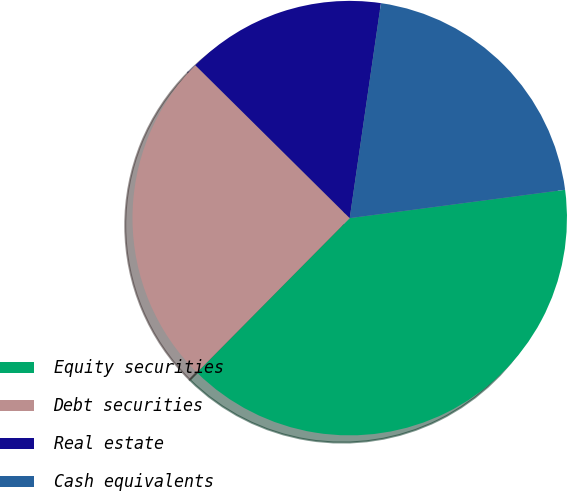<chart> <loc_0><loc_0><loc_500><loc_500><pie_chart><fcel>Equity securities<fcel>Debt securities<fcel>Real estate<fcel>Cash equivalents<nl><fcel>39.49%<fcel>25.01%<fcel>14.87%<fcel>20.62%<nl></chart> 